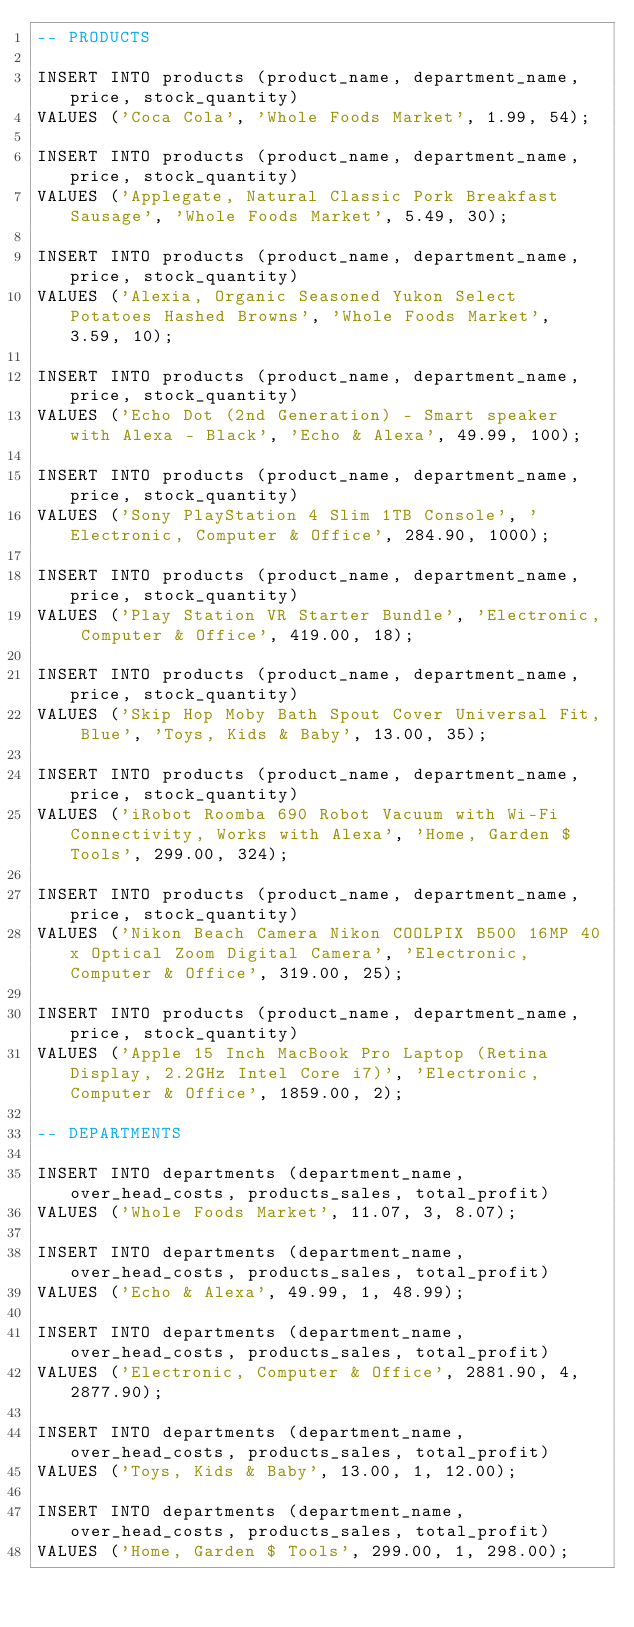<code> <loc_0><loc_0><loc_500><loc_500><_SQL_>-- PRODUCTS

INSERT INTO products (product_name, department_name, price, stock_quantity)
VALUES ('Coca Cola', 'Whole Foods Market', 1.99, 54);

INSERT INTO products (product_name, department_name, price, stock_quantity)
VALUES ('Applegate, Natural Classic Pork Breakfast Sausage', 'Whole Foods Market', 5.49, 30);

INSERT INTO products (product_name, department_name, price, stock_quantity)
VALUES ('Alexia, Organic Seasoned Yukon Select Potatoes Hashed Browns', 'Whole Foods Market', 3.59, 10);

INSERT INTO products (product_name, department_name, price, stock_quantity)
VALUES ('Echo Dot (2nd Generation) - Smart speaker with Alexa - Black', 'Echo & Alexa', 49.99, 100);

INSERT INTO products (product_name, department_name, price, stock_quantity)
VALUES ('Sony PlayStation 4 Slim 1TB Console', 'Electronic, Computer & Office', 284.90, 1000);

INSERT INTO products (product_name, department_name, price, stock_quantity)
VALUES ('Play Station VR Starter Bundle', 'Electronic, Computer & Office', 419.00, 18);

INSERT INTO products (product_name, department_name, price, stock_quantity)
VALUES ('Skip Hop Moby Bath Spout Cover Universal Fit, Blue', 'Toys, Kids & Baby', 13.00, 35);

INSERT INTO products (product_name, department_name, price, stock_quantity)
VALUES ('iRobot Roomba 690 Robot Vacuum with Wi-Fi Connectivity, Works with Alexa', 'Home, Garden $ Tools', 299.00, 324);

INSERT INTO products (product_name, department_name, price, stock_quantity)
VALUES ('Nikon Beach Camera Nikon COOLPIX B500 16MP 40x Optical Zoom Digital Camera', 'Electronic, Computer & Office', 319.00, 25);

INSERT INTO products (product_name, department_name, price, stock_quantity)
VALUES ('Apple 15 Inch MacBook Pro Laptop (Retina Display, 2.2GHz Intel Core i7)', 'Electronic, Computer & Office', 1859.00, 2);

-- DEPARTMENTS

INSERT INTO departments (department_name, over_head_costs, products_sales, total_profit)
VALUES ('Whole Foods Market', 11.07, 3, 8.07);

INSERT INTO departments (department_name, over_head_costs, products_sales, total_profit)
VALUES ('Echo & Alexa', 49.99, 1, 48.99);

INSERT INTO departments (department_name, over_head_costs, products_sales, total_profit)
VALUES ('Electronic, Computer & Office', 2881.90, 4, 2877.90);

INSERT INTO departments (department_name, over_head_costs, products_sales, total_profit)
VALUES ('Toys, Kids & Baby', 13.00, 1, 12.00);

INSERT INTO departments (department_name, over_head_costs, products_sales, total_profit)
VALUES ('Home, Garden $ Tools', 299.00, 1, 298.00);</code> 